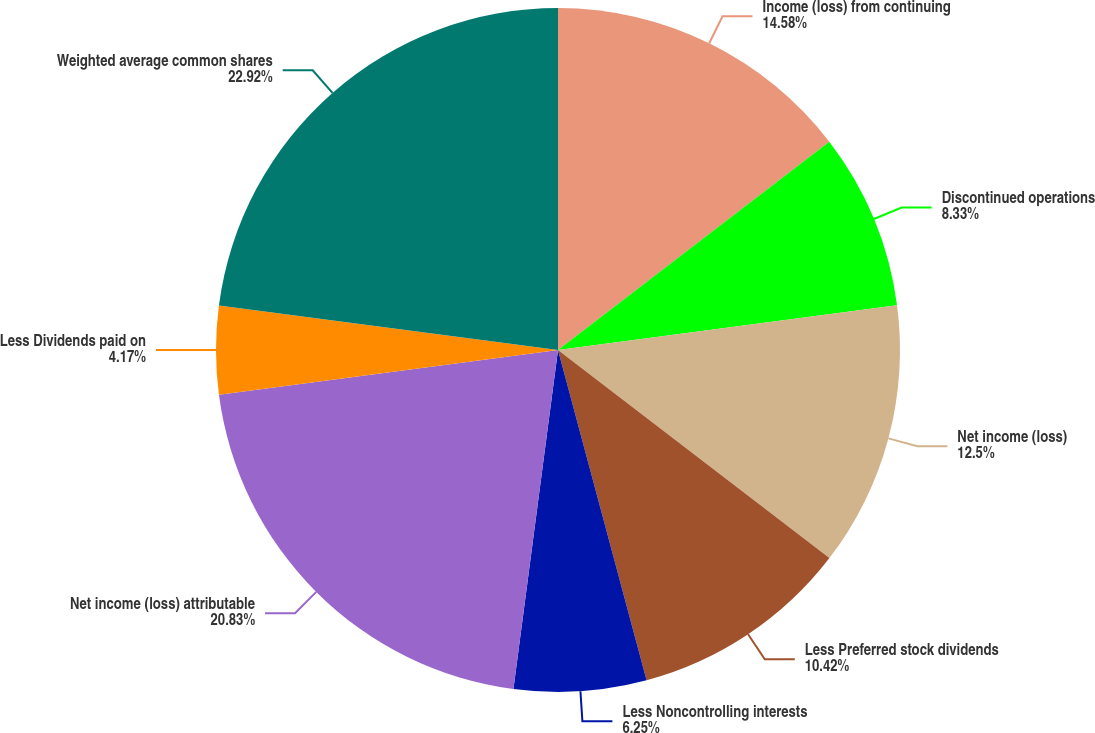<chart> <loc_0><loc_0><loc_500><loc_500><pie_chart><fcel>Income (loss) from continuing<fcel>Discontinued operations<fcel>Net income (loss)<fcel>Less Preferred stock dividends<fcel>Less Noncontrolling interests<fcel>Net income (loss) attributable<fcel>Less Dividends paid on<fcel>Weighted average common shares<nl><fcel>14.58%<fcel>8.33%<fcel>12.5%<fcel>10.42%<fcel>6.25%<fcel>20.83%<fcel>4.17%<fcel>22.92%<nl></chart> 